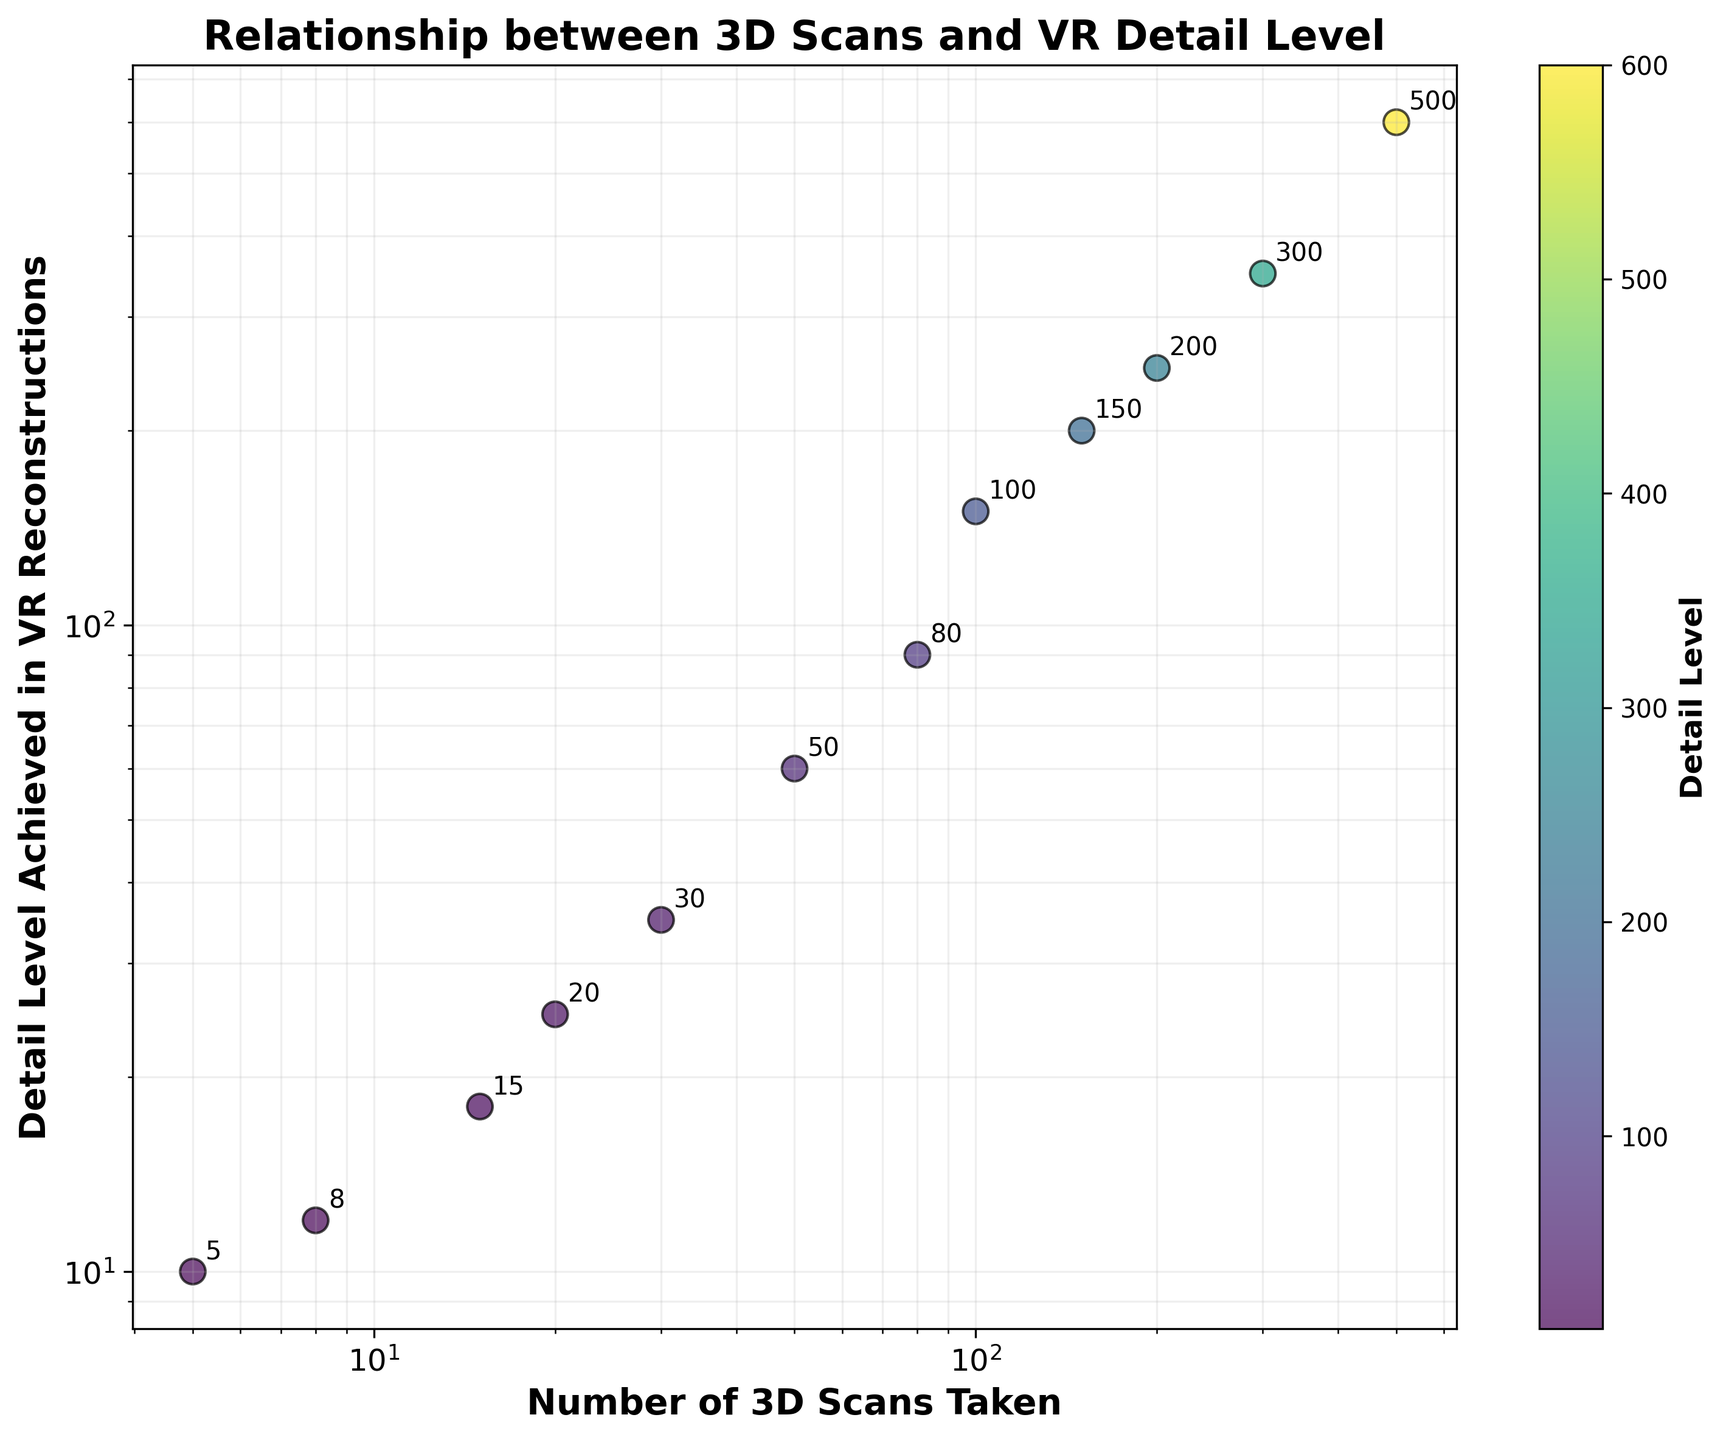what is the title of the figure? The title is prominently displayed at the top of the figure in bold and is intended to give an overall summary of what the scatter plot represents. In this case, the title is "Relationship between 3D Scans and VR Detail Level."
Answer: Relationship between 3D Scans and VR Detail Level How many data points are in the scatter plot? By visually inspecting the scatter plot, you can count the number of individual points or annotations displayed. There are 12 data points in total.
Answer: 12 What does the color of the data points represent? The color of the data points is indicated by the color bar on the right side of the plot. It represents the 'Detail Level' achieved in VR reconstructions.
Answer: Detail Level What are the x-axis and y-axis labels? The labels of the axes provide information about what each axis represents. The x-axis is labeled "Number of 3D Scans Taken," and the y-axis is labeled "Detail Level Achieved in VR Reconstructions."
Answer: Number of 3D Scans Taken; Detail Level Achieved in VR Reconstructions Is there a grid on the scatter plot? By looking at the plot, you can see light, faint lines that serve as a grid in both the x and y-directions. These lines help to better visualize the position of the data points.
Answer: Yes What is the detail level achieved for 200 3D scans taken? By locating the 200 (on the log scale) on the x-axis and following the corresponding point, you can find that the detail level achieved for 200 3D scans is 250.
Answer: 250 What is the general trend shown by the scatter plot? Most of the points show an upward trend as you move from left to right in the plot, suggesting that as the number of 3D scans taken increases, the detail level achieved also tends to increase.
Answer: Increasing trend How many data points have a detail level achieved of more than 100? By visually inspecting the y-axis and identifying points above the 100 mark, you can count the number of points. Data points for 100, 150, 200, 300, and 500 3D scans have detail levels achieved of more than 100. Thus, there are 5 such data points.
Answer: 5 What is the difference in detail level achieved between scans taken at 100 and 200? From the scatter plot, the detail level achieved for 100 scans is 150, and for 200 scans is 250. The difference (250 - 150) is 100.
Answer: 100 What can be inferred if a point lies at the top-right corner of the plot? Points towards the top-right of the log-log scale scatter plot indicate higher values on both the x-axis and y-axis, meaning a high number of 3D scans taken and a high detail level achieved in VR reconstructions.
Answer: High number of 3D scans and high-detail level 